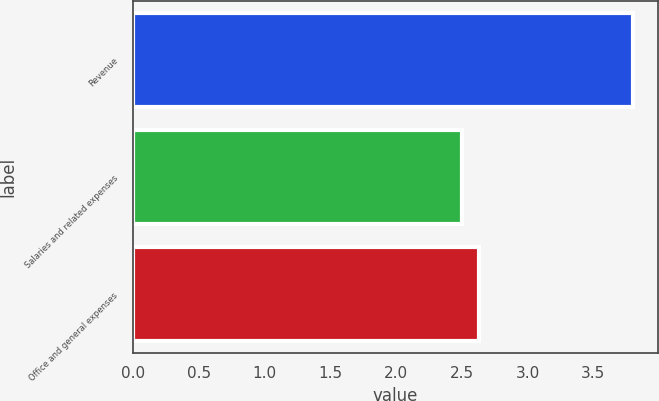Convert chart. <chart><loc_0><loc_0><loc_500><loc_500><bar_chart><fcel>Revenue<fcel>Salaries and related expenses<fcel>Office and general expenses<nl><fcel>3.8<fcel>2.5<fcel>2.63<nl></chart> 